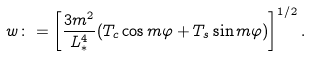Convert formula to latex. <formula><loc_0><loc_0><loc_500><loc_500>w \colon = \left [ \frac { 3 m ^ { 2 } } { L _ { * } ^ { 4 } } ( T _ { c } \cos { m \varphi } + T _ { s } \sin { m \varphi } ) \right ] ^ { 1 / 2 } .</formula> 